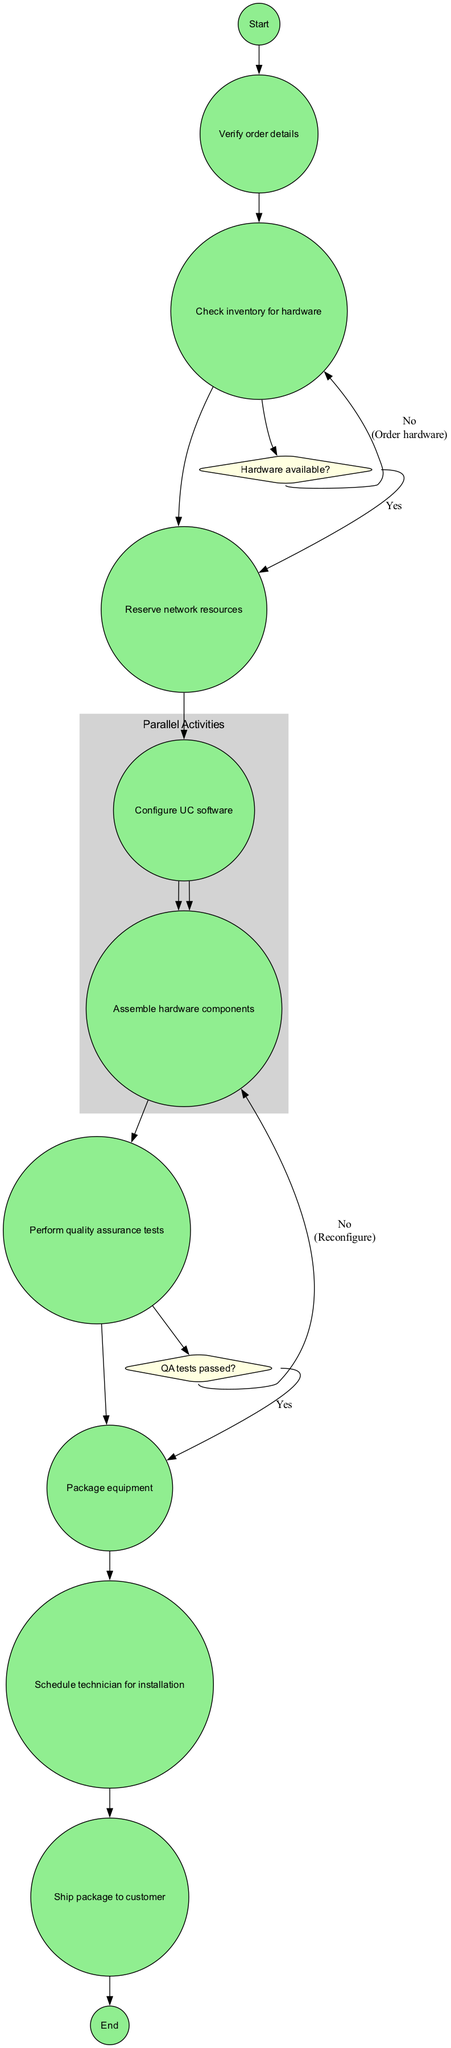What is the initial action in the diagram? The initial action is represented as the first activity node. This node is labeled "Receive customer order," making it the starting point of the process.
Answer: Receive customer order How many activities are in the diagram? To find the total number of activities, count the entries listed in the "activities" section of the data. There are nine activities clearly listed.
Answer: 9 What decision follows the "Check inventory for hardware" activity? The decision directly associated after this activity can be found by tracing the flow from "Check inventory for hardware" to the next node. This leads to the question node labeled "Hardware available?"
Answer: Hardware available? What happens if the quality assurance tests do not pass? The flow from the decision node "QA tests passed?" indicates that if this is answered with "No," the diagram directs to "Troubleshoot and reconfigure."
Answer: Troubleshoot and reconfigure How are the "Configure UC software" and "Assemble hardware components" activities related? These two activities are linked as parallel activities. The diagram shows them occurring simultaneously, with their flow starting from a single node.
Answer: Parallel activities What is the final action in the order fulfillment process? The final action of the process can be seen in the last node which states "Close order and update customer record." This marks the end of the fulfillment process.
Answer: Close order and update customer record If hardware is not available, what is the subsequent action? The diagram specifies that if the decision at "Hardware available?" is "No," the next action to take is to "Order additional hardware."
Answer: Order additional hardware What activity occurs right before the packaging of the equipment? To determine the activity prior to packaging, trace the flow from the previous steps, leading directly to the node labeled "Perform quality assurance tests."
Answer: Perform quality assurance tests How many decision points are included in the diagram? Count the number of decision nodes present in the flow of the diagram. There are two decisions specifically illustrated in the data under "decisions."
Answer: 2 